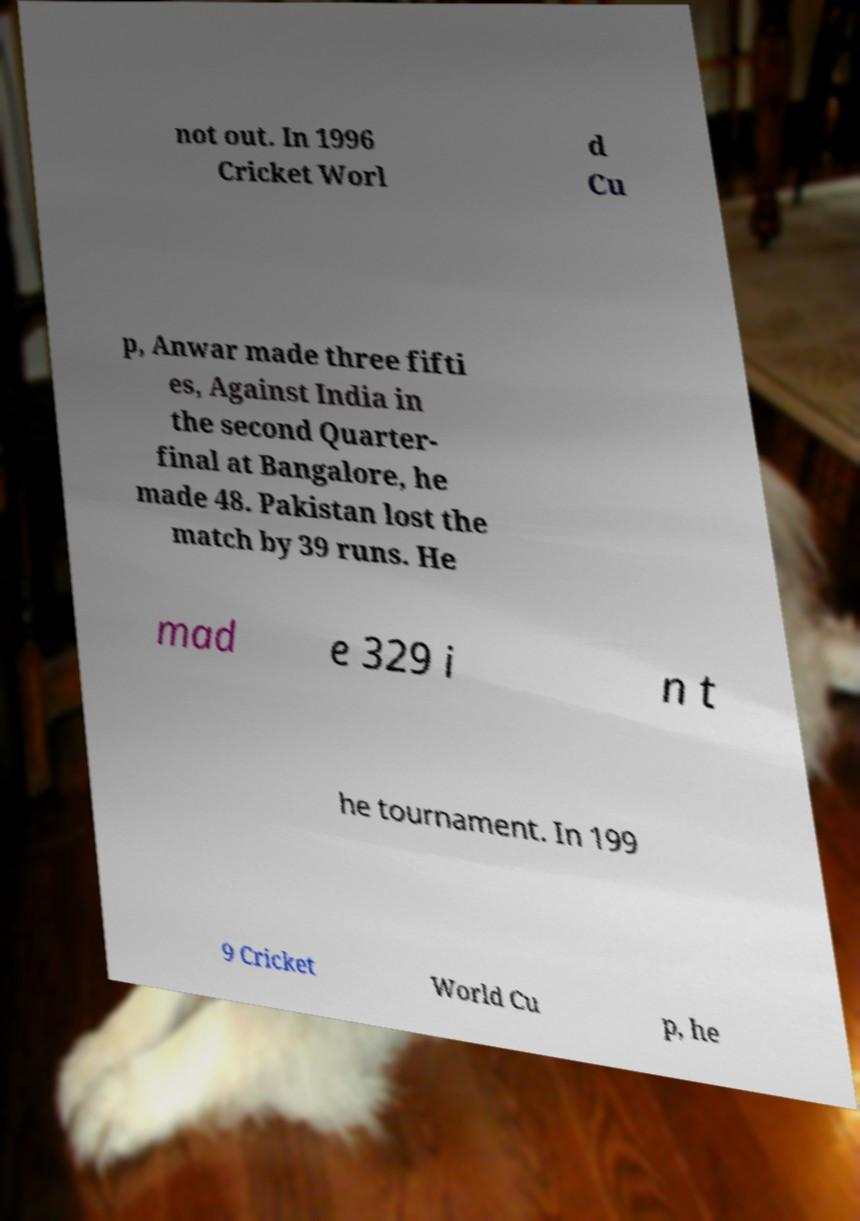What messages or text are displayed in this image? I need them in a readable, typed format. not out. In 1996 Cricket Worl d Cu p, Anwar made three fifti es, Against India in the second Quarter- final at Bangalore, he made 48. Pakistan lost the match by 39 runs. He mad e 329 i n t he tournament. In 199 9 Cricket World Cu p, he 